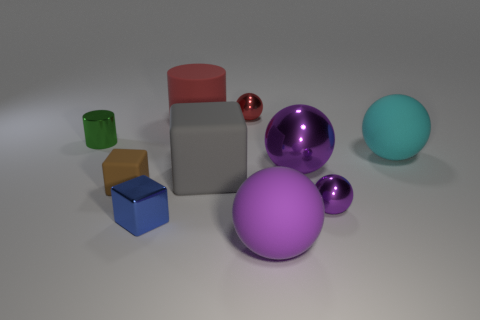The small green metal object left of the cylinder that is to the right of the small cylinder in front of the big cylinder is what shape?
Provide a short and direct response. Cylinder. The tiny metallic thing that is in front of the small brown thing and right of the tiny blue object has what shape?
Your response must be concise. Sphere. Is there a cyan ball that has the same material as the small brown object?
Make the answer very short. Yes. There is a shiny ball that is the same color as the large metal thing; what size is it?
Provide a short and direct response. Small. What color is the sphere that is on the right side of the small purple metallic ball?
Ensure brevity in your answer.  Cyan. Is the shape of the red matte object the same as the large purple object that is behind the large purple rubber sphere?
Your answer should be compact. No. Are there any large things of the same color as the tiny cylinder?
Keep it short and to the point. No. There is a red object that is made of the same material as the cyan ball; what is its size?
Your response must be concise. Large. Does the matte cylinder have the same color as the big metallic ball?
Offer a very short reply. No. Do the big matte object behind the cyan rubber object and the gray rubber object have the same shape?
Ensure brevity in your answer.  No. 